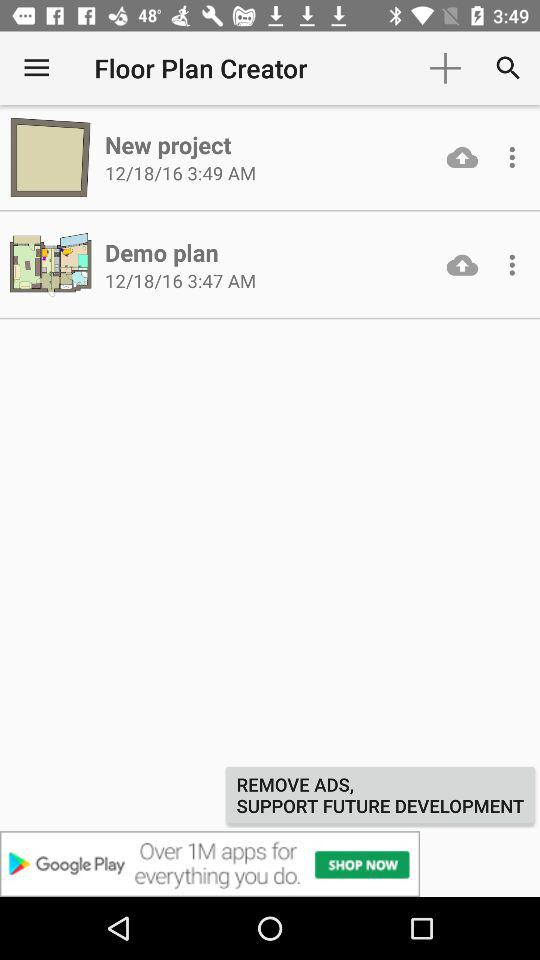On what date was "New Project" created? The "New Project" was created on December 18, 2016. 